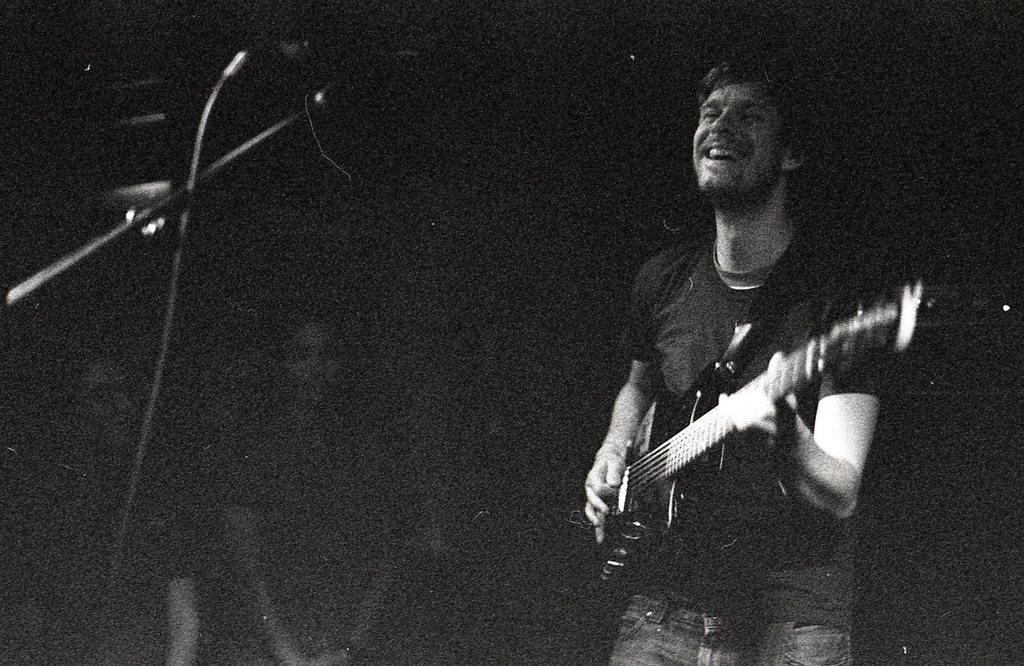In one or two sentences, can you explain what this image depicts? In this picture we can see man holding guitar in his hand and playing it and singing on mic and in background we can see some persons and it is dark. 